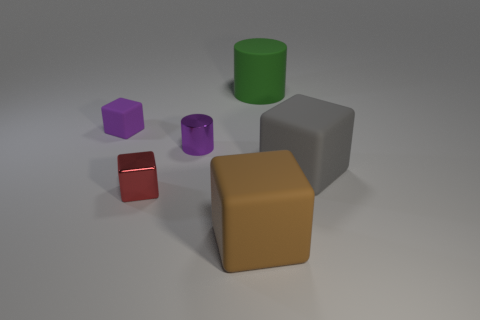What could be the function of these objects in a real-world setting? In a real-world setting, these geometric shapes could represent a variety of objects. The green cylinder could be a cup or container, the purple objects could be toy blocks, the red cube might be a dice, and the larger gray and tan blocks could be placeholders for furniture or architectural models. 